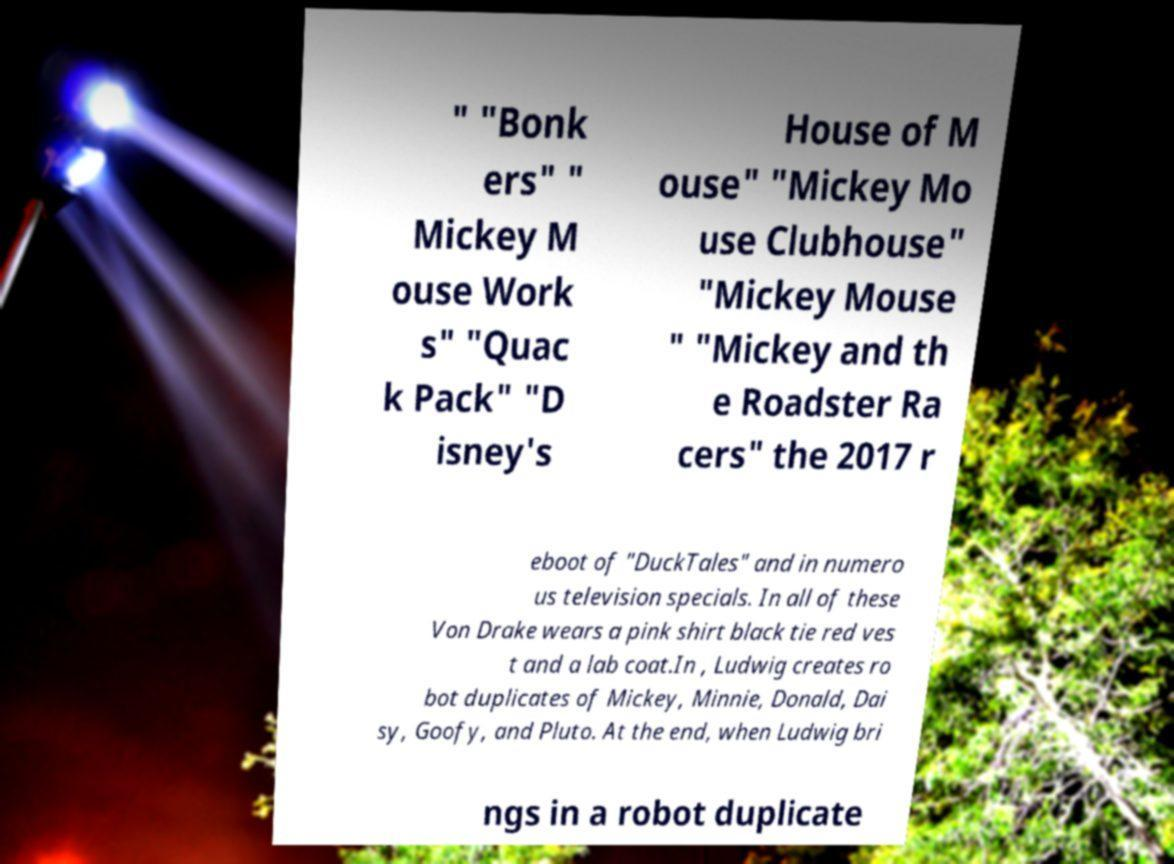There's text embedded in this image that I need extracted. Can you transcribe it verbatim? " "Bonk ers" " Mickey M ouse Work s" "Quac k Pack" "D isney's House of M ouse" "Mickey Mo use Clubhouse" "Mickey Mouse " "Mickey and th e Roadster Ra cers" the 2017 r eboot of "DuckTales" and in numero us television specials. In all of these Von Drake wears a pink shirt black tie red ves t and a lab coat.In , Ludwig creates ro bot duplicates of Mickey, Minnie, Donald, Dai sy, Goofy, and Pluto. At the end, when Ludwig bri ngs in a robot duplicate 